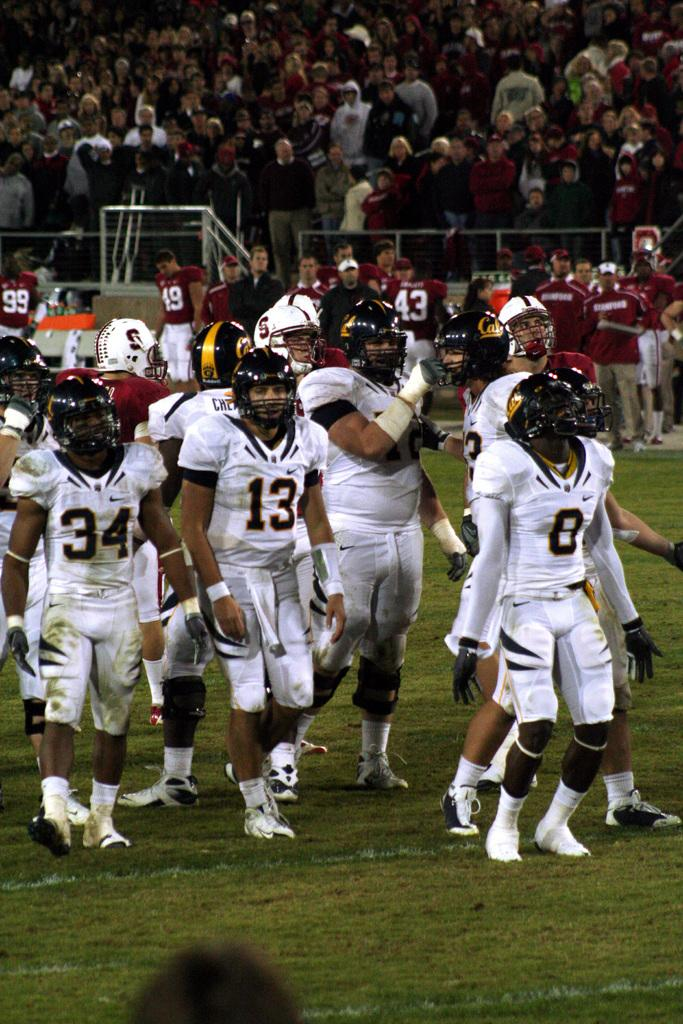What are the persons in the foreground of the image wearing? The persons in the foreground of the image are wearing helmets. What is the surface on which the persons in the foreground are standing? The persons in the foreground are standing on the grass. What can be seen in the background of the image? There are persons standing in the background of the image, along with railing and a crowd. What type of rail can be seen connecting the two buildings in the alley in the image? There is no alley or connecting rail between buildings present in the image. 